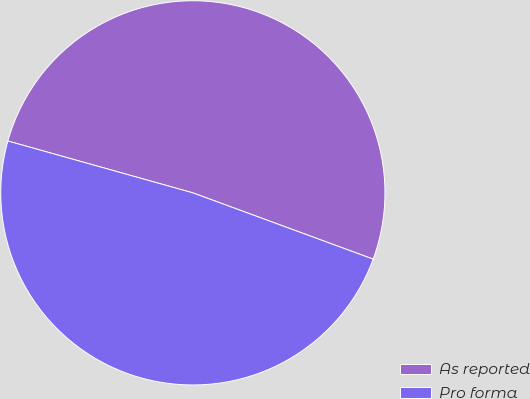Convert chart to OTSL. <chart><loc_0><loc_0><loc_500><loc_500><pie_chart><fcel>As reported<fcel>Pro forma<nl><fcel>51.26%<fcel>48.74%<nl></chart> 